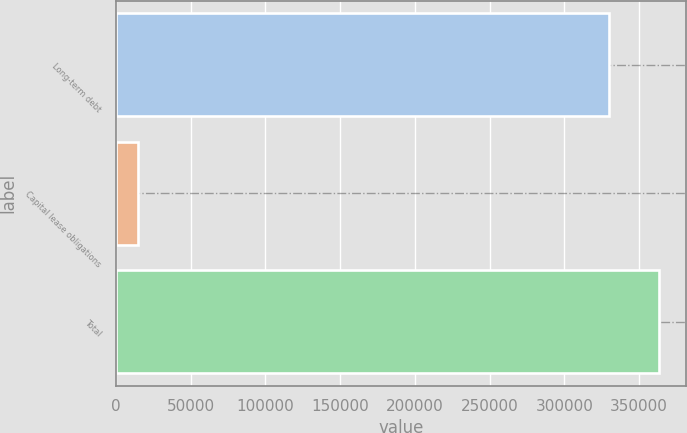<chart> <loc_0><loc_0><loc_500><loc_500><bar_chart><fcel>Long-term debt<fcel>Capital lease obligations<fcel>Total<nl><fcel>330000<fcel>14516<fcel>363000<nl></chart> 